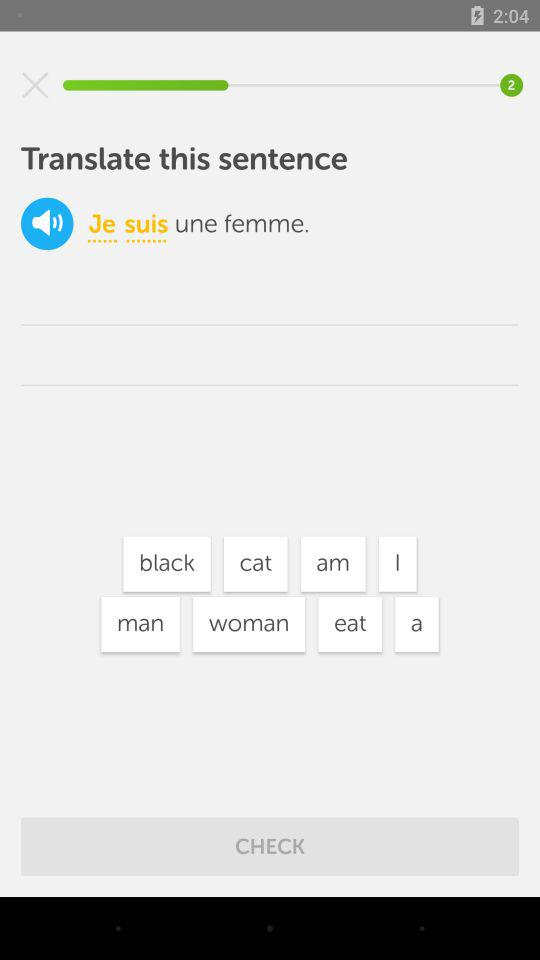How many total pages are there?
When the provided information is insufficient, respond with <no answer>. <no answer> 